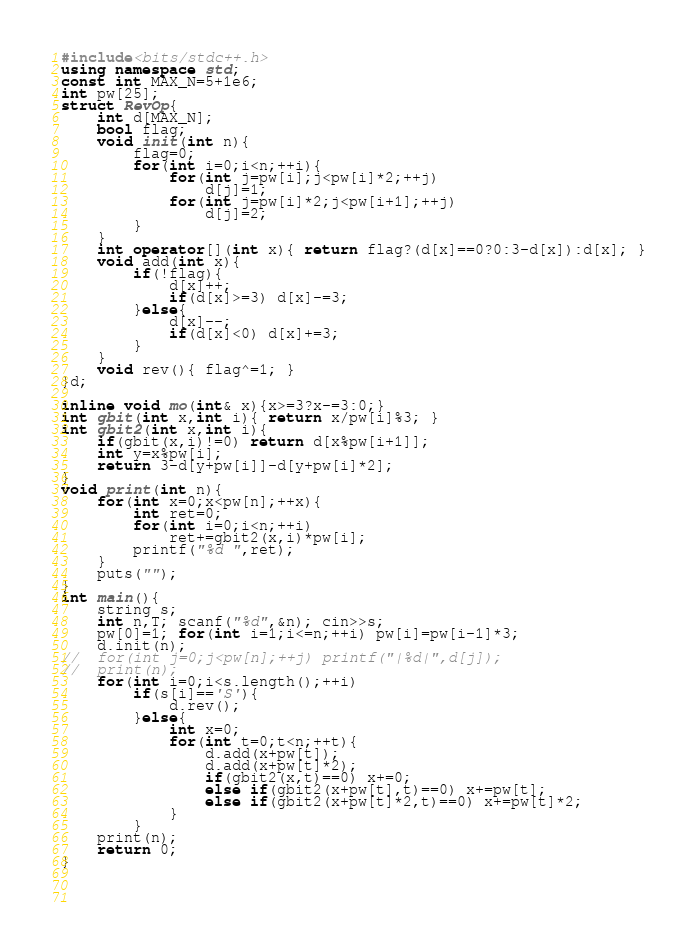Convert code to text. <code><loc_0><loc_0><loc_500><loc_500><_C++_>#include<bits/stdc++.h>
using namespace std;
const int MAX_N=5+1e6;
int pw[25];
struct RevOp{
	int d[MAX_N];
	bool flag;
	void init(int n){
		flag=0;
		for(int i=0;i<n;++i){
			for(int j=pw[i];j<pw[i]*2;++j)
				d[j]=1;
			for(int j=pw[i]*2;j<pw[i+1];++j)
				d[j]=2;
		}
	}
	int operator[](int x){ return flag?(d[x]==0?0:3-d[x]):d[x]; }
	void add(int x){ 
		if(!flag){
			d[x]++; 
			if(d[x]>=3) d[x]-=3; 
		}else{
			d[x]--;
			if(d[x]<0) d[x]+=3;
		}
	}
	void rev(){ flag^=1; }
}d;

inline void mo(int& x){x>=3?x-=3:0;}
int gbit(int x,int i){ return x/pw[i]%3; }
int gbit2(int x,int i){
	if(gbit(x,i)!=0) return d[x%pw[i+1]];
	int y=x%pw[i];
	return 3-d[y+pw[i]]-d[y+pw[i]*2];
}
void print(int n){
	for(int x=0;x<pw[n];++x){
		int ret=0;
		for(int i=0;i<n;++i)
			ret+=gbit2(x,i)*pw[i];
		printf("%d ",ret);
	}
	puts("");
}
int main(){
	string s;
	int n,T; scanf("%d",&n); cin>>s;
	pw[0]=1; for(int i=1;i<=n;++i) pw[i]=pw[i-1]*3;
	d.init(n);
//	for(int j=0;j<pw[n];++j) printf("|%d|",d[j]);
//	print(n);
	for(int i=0;i<s.length();++i)
		if(s[i]=='S'){
			d.rev();
		}else{
			int x=0;
			for(int t=0;t<n;++t){
				d.add(x+pw[t]);
				d.add(x+pw[t]*2);
				if(gbit2(x,t)==0) x+=0;
				else if(gbit2(x+pw[t],t)==0) x+=pw[t];
				else if(gbit2(x+pw[t]*2,t)==0) x+=pw[t]*2;
			}
		}
	print(n);
	return 0;
}
	
					
			</code> 